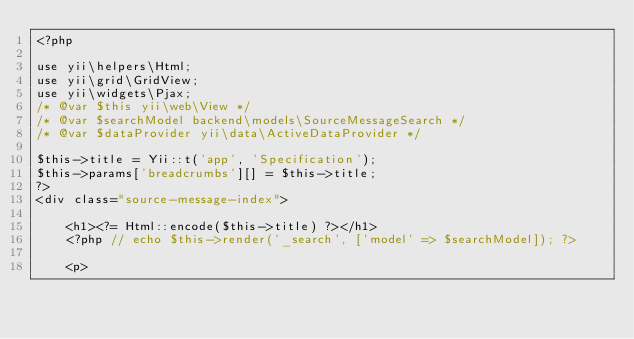Convert code to text. <code><loc_0><loc_0><loc_500><loc_500><_PHP_><?php

use yii\helpers\Html;
use yii\grid\GridView;
use yii\widgets\Pjax;
/* @var $this yii\web\View */
/* @var $searchModel backend\models\SourceMessageSearch */
/* @var $dataProvider yii\data\ActiveDataProvider */

$this->title = Yii::t('app', 'Specification');
$this->params['breadcrumbs'][] = $this->title;
?>
<div class="source-message-index">

    <h1><?= Html::encode($this->title) ?></h1>
    <?php // echo $this->render('_search', ['model' => $searchModel]); ?>

    <p></code> 